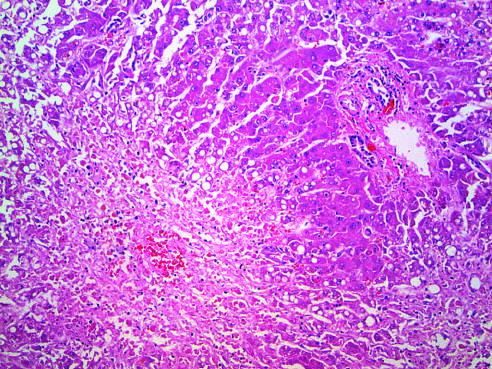what is residual normal tissue indicated by?
Answer the question using a single word or phrase. The asterisk 